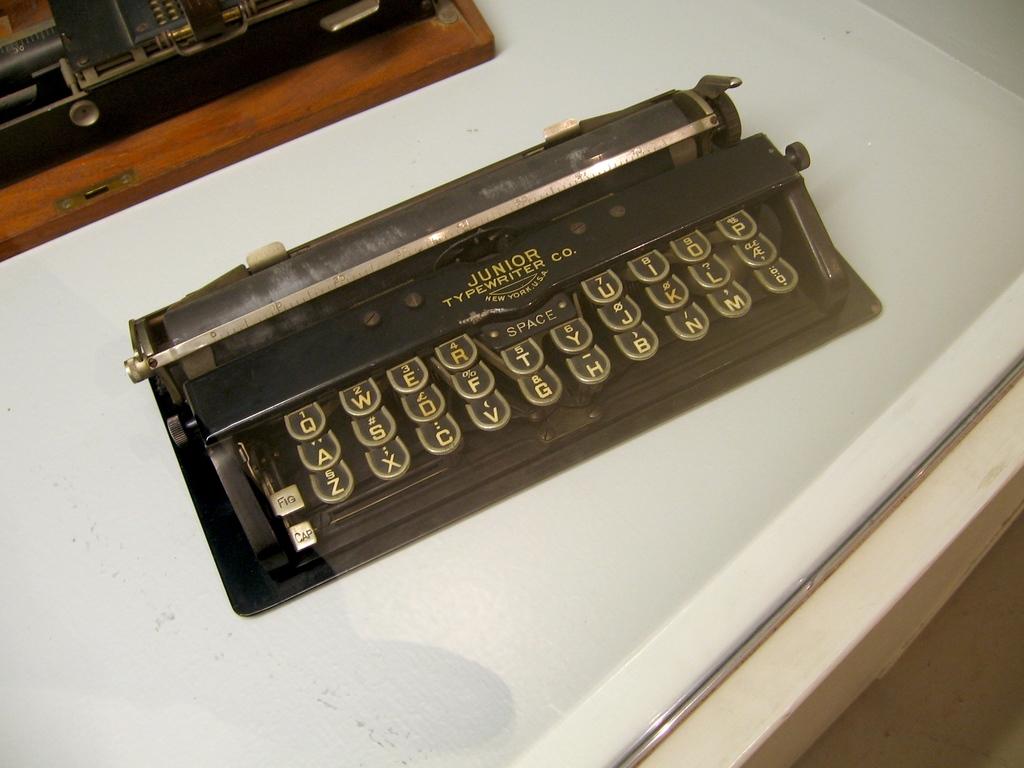What type of typewriter is this?
Provide a short and direct response. Junior. Junior typewriter co?
Provide a short and direct response. Yes. 